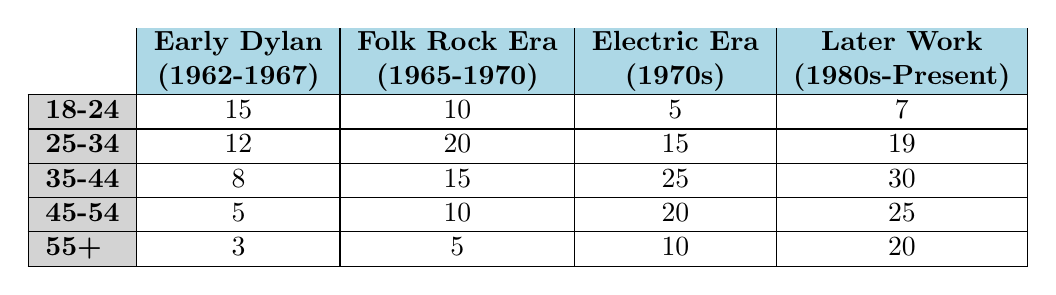What is the highest number of listeners in the 35-44 age group for any Bob Dylan era? In the 35-44 age group, the largest number of listeners is for "Later Work (1980s-Present)" with 30 listeners.
Answer: 30 Which age group has the lowest preference for the "Early Dylan (1962-1967)" era? The age group with the lowest preference for the "Early Dylan (1962-1967)" era is "55+" with only 3 listeners.
Answer: 3 How many total listeners in the 25-34 age group prefer the "Electric Era (1970s)"? The "Electric Era (1970s)" in the 25-34 age group has 15 listeners, which is a direct retrieval from the table without needing further calculations.
Answer: 15 What is the average number of listeners across all age groups for the "Folk Rock Era (1965-1970)"? To find the average, sum the listeners for the "Folk Rock Era (1965-1970)" across all age groups: 10 + 20 + 15 + 10 + 5 = 70. There are 5 age groups, so the average is 70/5 = 14.
Answer: 14 Is there a higher total number of listeners for "Later Work (1980s-Present)" than "Electric Era (1970s)" across all age groups? To check this, we sum the listeners for both eras. For "Later Work (1980s-Present)": 7 + 19 + 30 + 25 + 20 = 101. For "Electric Era (1970s)": 5 + 15 + 25 + 20 + 10 = 75. Since 101 > 75, the statement is true.
Answer: Yes Which age group has the highest preference for "Folk Rock Era (1965-1970)" and how many listeners does it have? The age group with the highest preference for "Folk Rock Era (1965-1970)" is "25-34," with 20 listeners as shown in the cross-section of the table.
Answer: 25-34 age group with 20 listeners What is the difference in listener numbers between the "Electric Era (1970s)" and "Later Work (1980s-Present)" for the 45-54 age group? For the 45-54 age group, there are 20 listeners for "Electric Era (1970s)" and 25 listeners for "Later Work (1980s-Present)". The difference is 25 - 20 = 5.
Answer: 5 Is the number of listeners for "Early Dylan (1962-1967)" in the 18-24 age group greater than that in the 55+ age group? The "Early Dylan (1962-1967)" has 15 listeners in the 18-24 age group and only 3 listeners in the 55+ age group. 15 > 3, so the statement is true.
Answer: Yes What is the total number of listeners for the "Folk Rock Era (1965-1970)" across all age groups? To find the total, sum the listeners from each age group: 10 + 20 + 15 + 10 + 5 = 60.
Answer: 60 